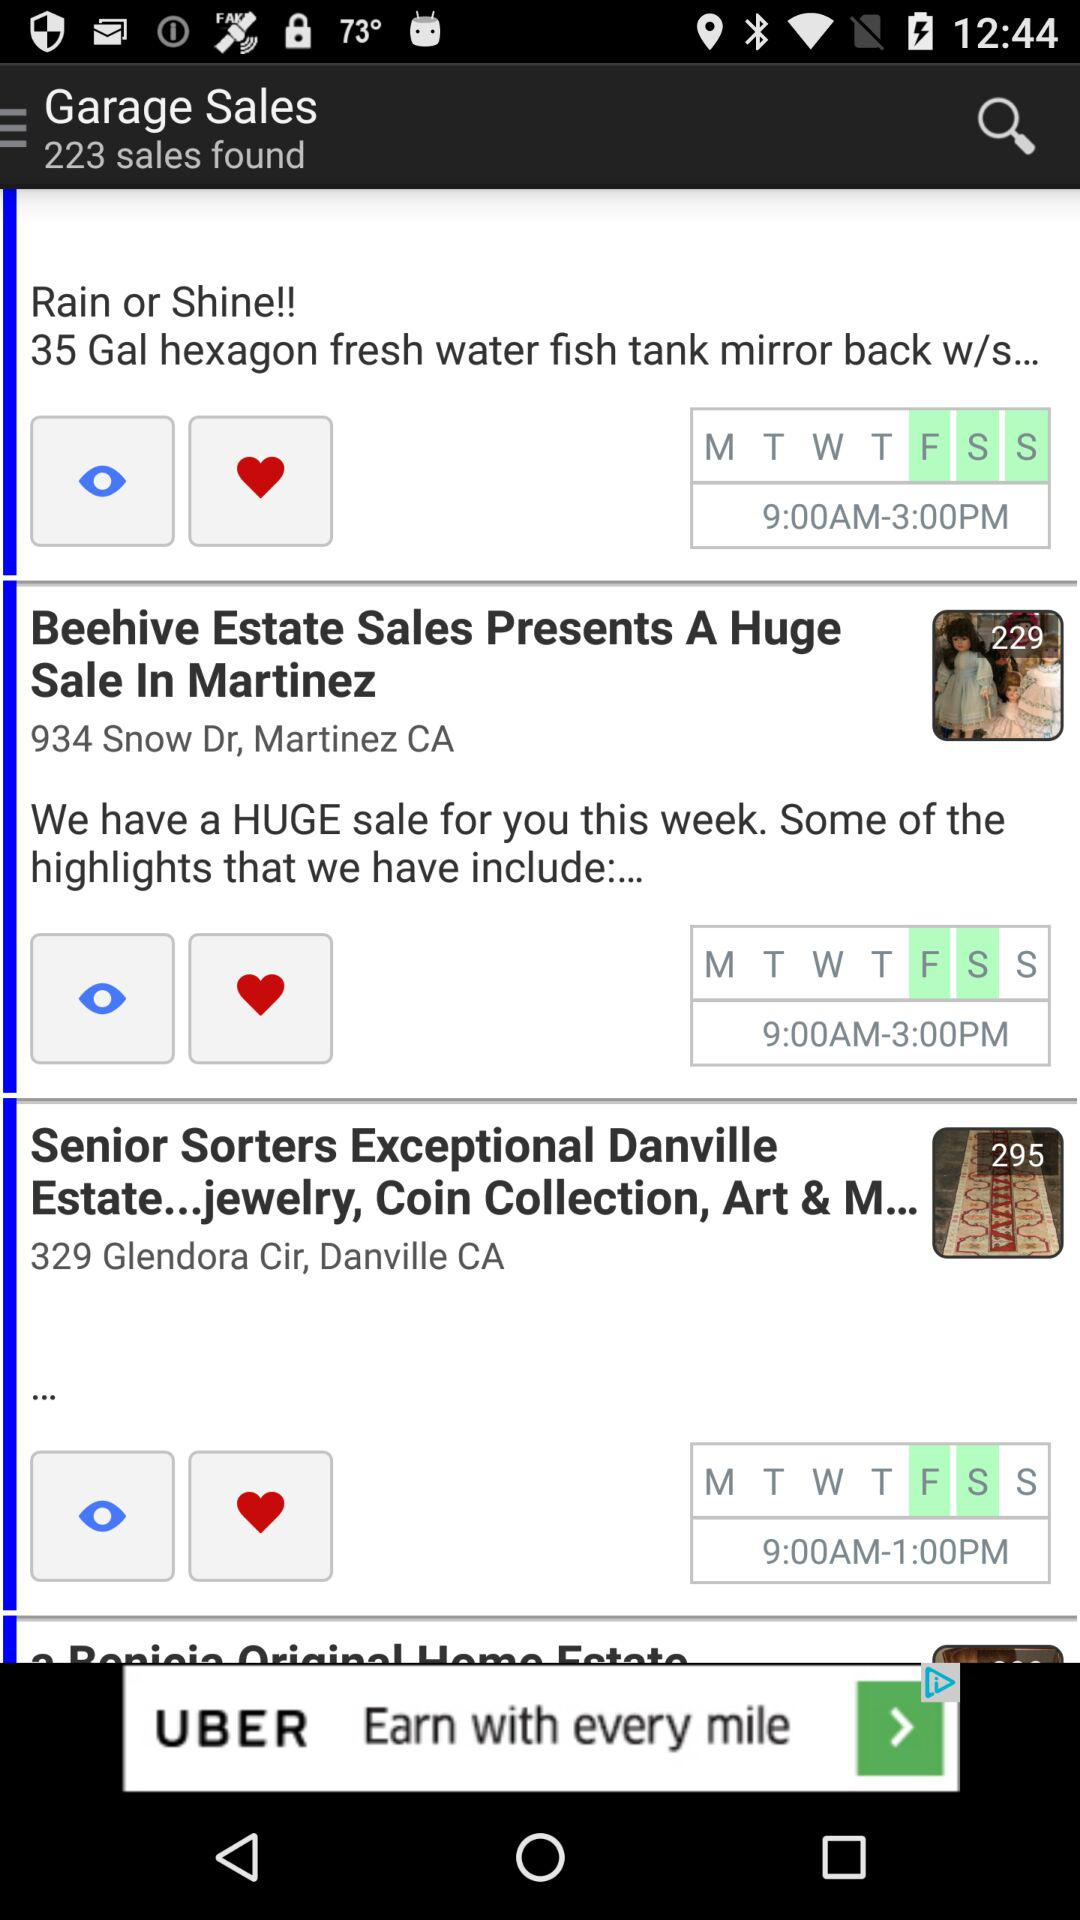How many sales have been found in total? There have been 223 sales found. 